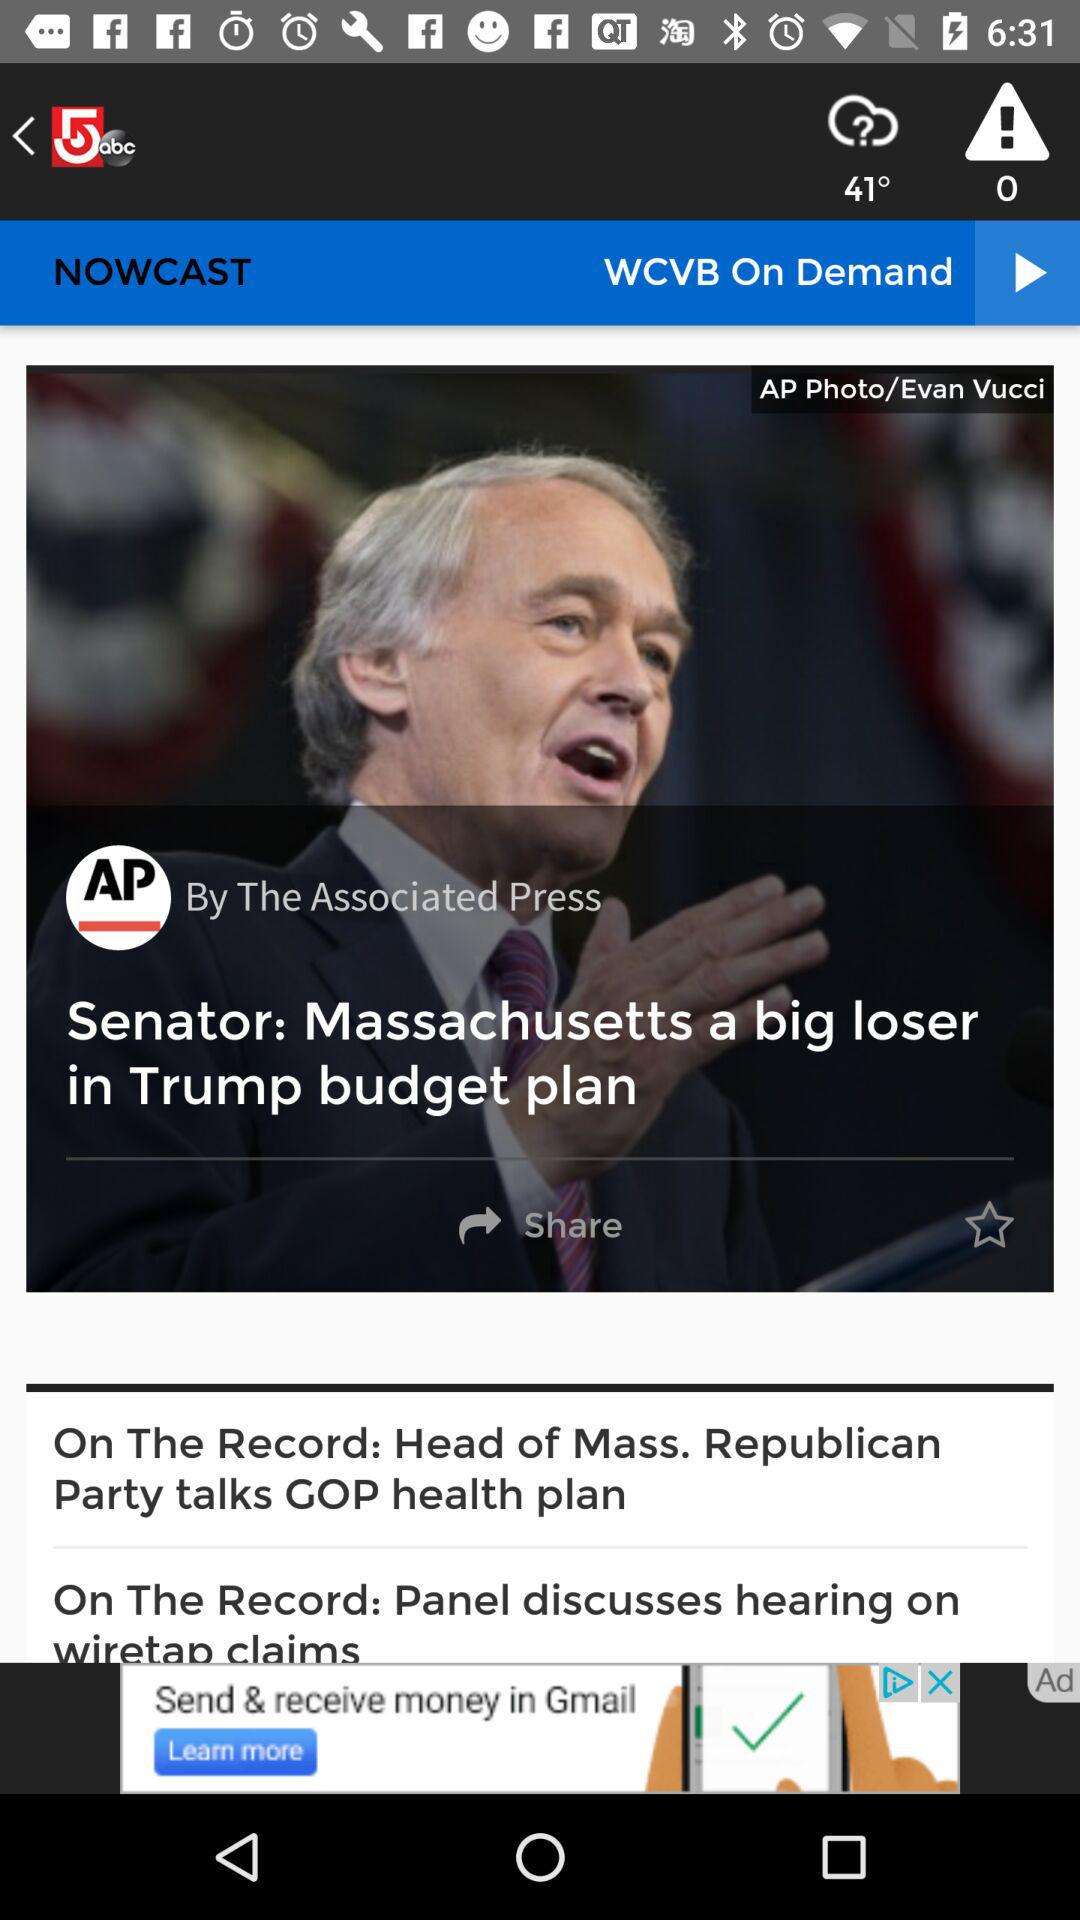What's the temperature? The temperature is 41°. 